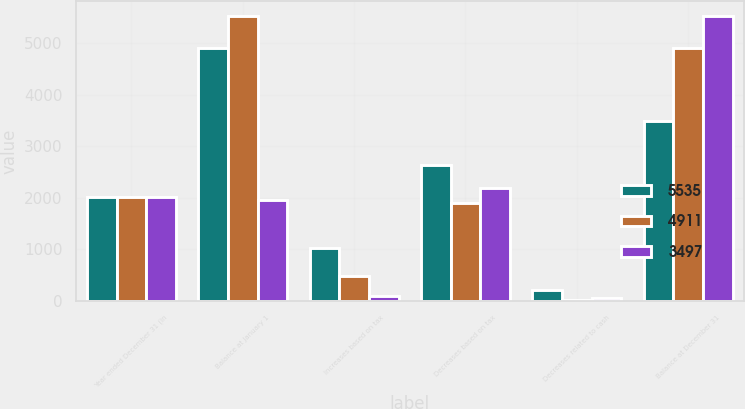<chart> <loc_0><loc_0><loc_500><loc_500><stacked_bar_chart><ecel><fcel>Year ended December 31 (in<fcel>Balance at January 1<fcel>Increases based on tax<fcel>Decreases based on tax<fcel>Decreases related to cash<fcel>Balance at December 31<nl><fcel>5535<fcel>2015<fcel>4911<fcel>1028<fcel>2646<fcel>204<fcel>3497<nl><fcel>4911<fcel>2014<fcel>5535<fcel>477<fcel>1902<fcel>9<fcel>4911<nl><fcel>3497<fcel>2013<fcel>1957.5<fcel>88<fcel>2200<fcel>53<fcel>5535<nl></chart> 